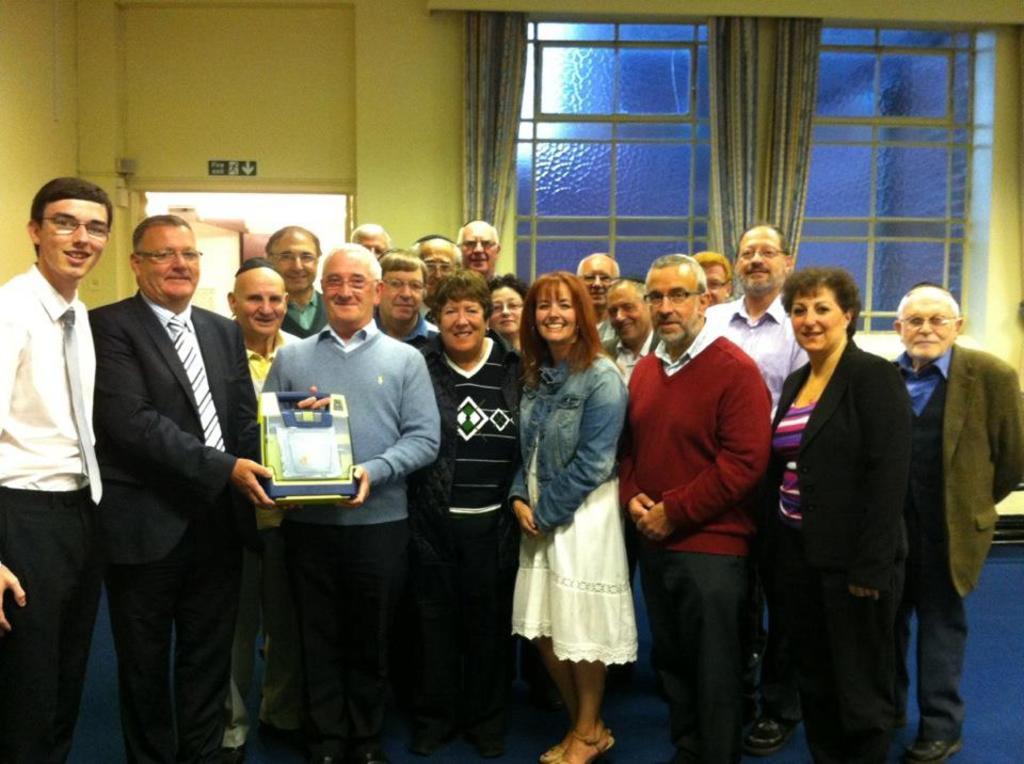How would you summarize this image in a sentence or two? In this image we can see persons standing on the floor and one of them is holding an object in the hands. In the background we can see windows, curtains, walls and a sign board. 